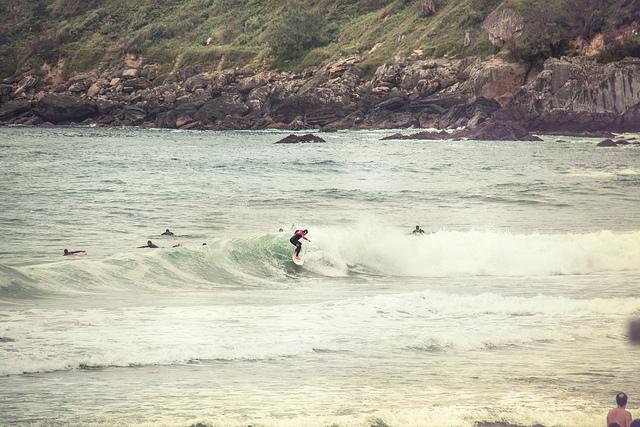What other activity can be carried out here besides surfing? Please explain your reasoning. swimming. People love to swim in the ocean. 